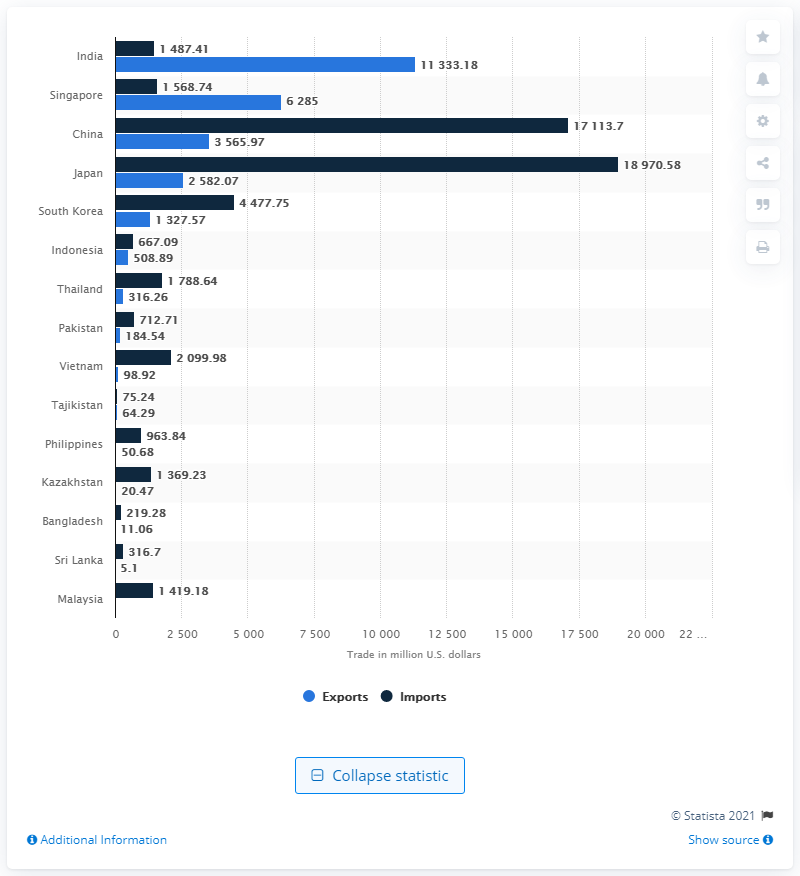List a handful of essential elements in this visual. In 2014, the value of pharmaceutical exports from Indonesia was 508.89 million US dollars. In 2014, Indonesia imported pharmaceutical goods worth 667.09 million US dollars. 